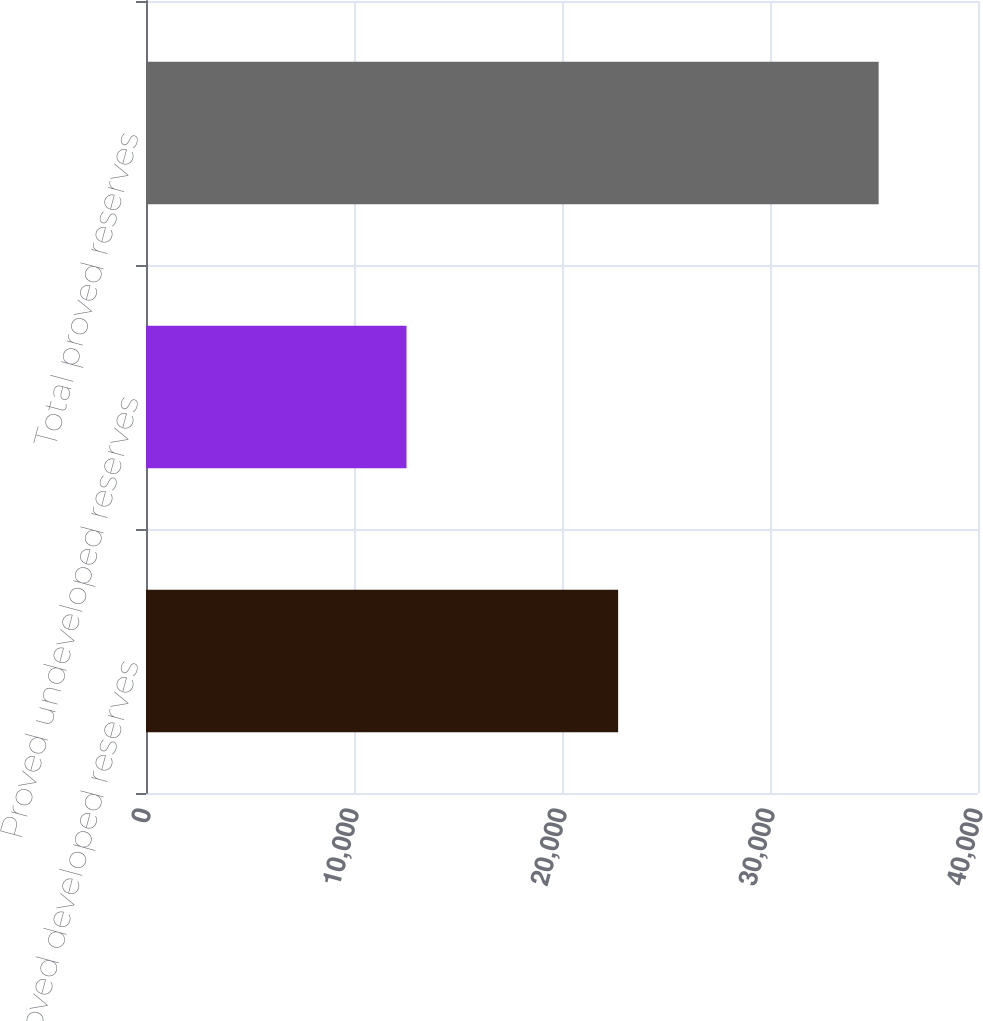Convert chart. <chart><loc_0><loc_0><loc_500><loc_500><bar_chart><fcel>Proved developed reserves<fcel>Proved undeveloped reserves<fcel>Total proved reserves<nl><fcel>22699<fcel>12525<fcel>35224<nl></chart> 